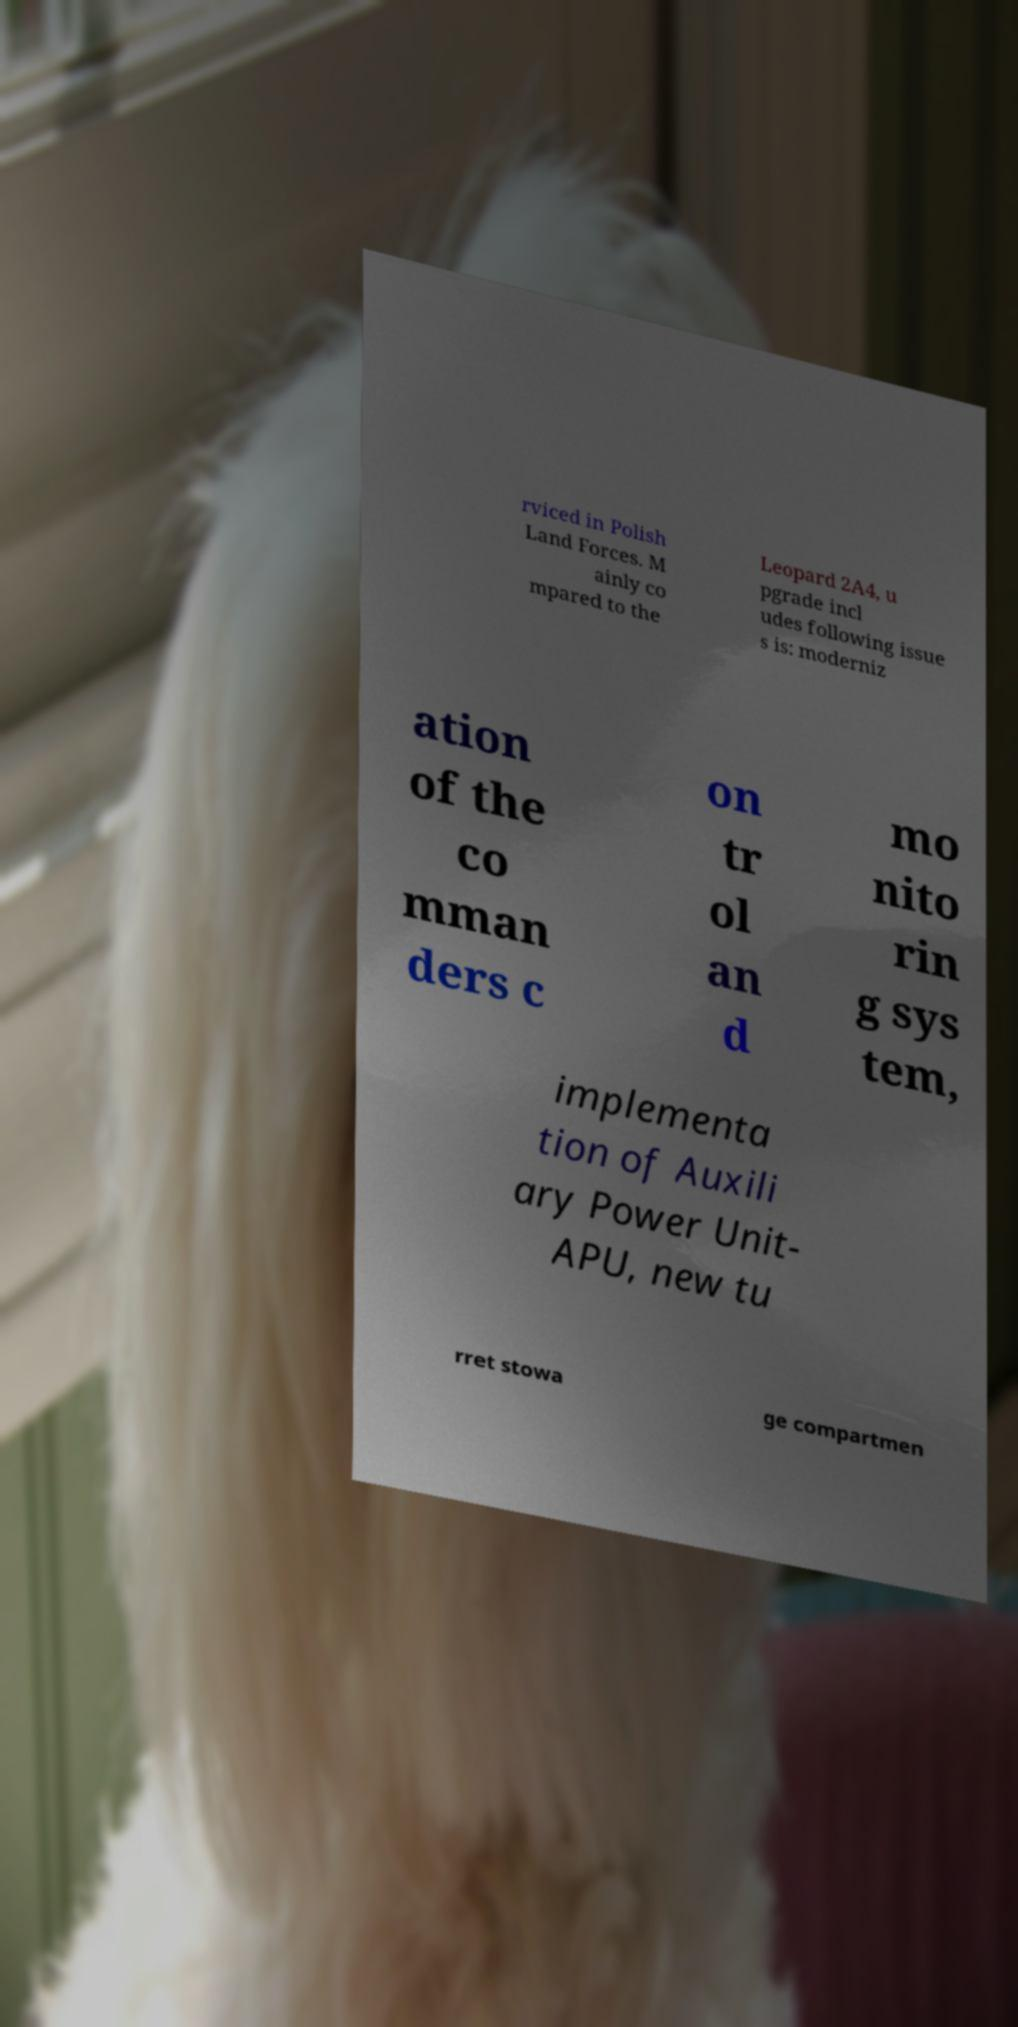There's text embedded in this image that I need extracted. Can you transcribe it verbatim? rviced in Polish Land Forces. M ainly co mpared to the Leopard 2A4, u pgrade incl udes following issue s is: moderniz ation of the co mman ders c on tr ol an d mo nito rin g sys tem, implementa tion of Auxili ary Power Unit- APU, new tu rret stowa ge compartmen 